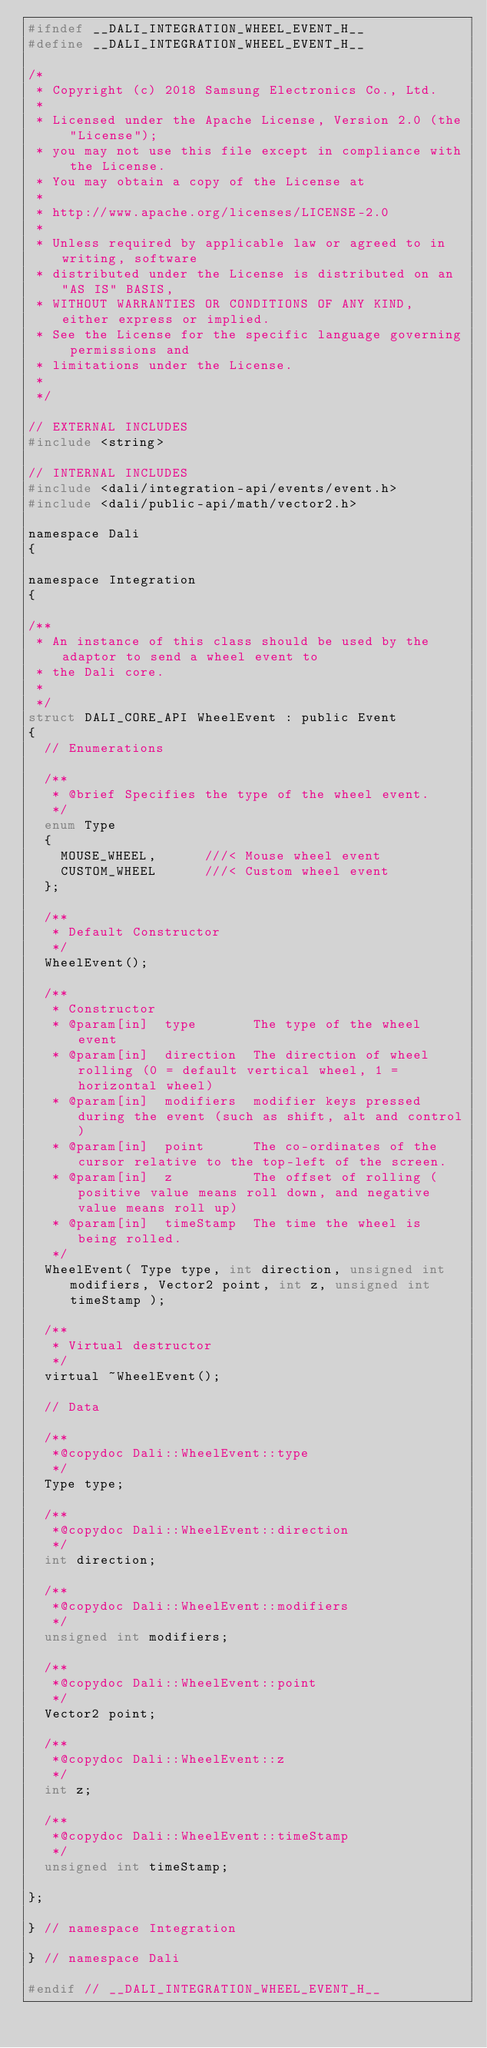<code> <loc_0><loc_0><loc_500><loc_500><_C_>#ifndef __DALI_INTEGRATION_WHEEL_EVENT_H__
#define __DALI_INTEGRATION_WHEEL_EVENT_H__

/*
 * Copyright (c) 2018 Samsung Electronics Co., Ltd.
 *
 * Licensed under the Apache License, Version 2.0 (the "License");
 * you may not use this file except in compliance with the License.
 * You may obtain a copy of the License at
 *
 * http://www.apache.org/licenses/LICENSE-2.0
 *
 * Unless required by applicable law or agreed to in writing, software
 * distributed under the License is distributed on an "AS IS" BASIS,
 * WITHOUT WARRANTIES OR CONDITIONS OF ANY KIND, either express or implied.
 * See the License for the specific language governing permissions and
 * limitations under the License.
 *
 */

// EXTERNAL INCLUDES
#include <string>

// INTERNAL INCLUDES
#include <dali/integration-api/events/event.h>
#include <dali/public-api/math/vector2.h>

namespace Dali
{

namespace Integration
{

/**
 * An instance of this class should be used by the adaptor to send a wheel event to
 * the Dali core.
 *
 */
struct DALI_CORE_API WheelEvent : public Event
{
  // Enumerations

  /**
   * @brief Specifies the type of the wheel event.
   */
  enum Type
  {
    MOUSE_WHEEL,      ///< Mouse wheel event
    CUSTOM_WHEEL      ///< Custom wheel event
  };

  /**
   * Default Constructor
   */
  WheelEvent();

  /**
   * Constructor
   * @param[in]  type       The type of the wheel event
   * @param[in]  direction  The direction of wheel rolling (0 = default vertical wheel, 1 = horizontal wheel)
   * @param[in]  modifiers  modifier keys pressed during the event (such as shift, alt and control)
   * @param[in]  point      The co-ordinates of the cursor relative to the top-left of the screen.
   * @param[in]  z          The offset of rolling (positive value means roll down, and negative value means roll up)
   * @param[in]  timeStamp  The time the wheel is being rolled.
   */
  WheelEvent( Type type, int direction, unsigned int modifiers, Vector2 point, int z, unsigned int timeStamp );

  /**
   * Virtual destructor
   */
  virtual ~WheelEvent();

  // Data

  /**
   *@copydoc Dali::WheelEvent::type
   */
  Type type;

  /**
   *@copydoc Dali::WheelEvent::direction
   */
  int direction;

  /**
   *@copydoc Dali::WheelEvent::modifiers
   */
  unsigned int modifiers;

  /**
   *@copydoc Dali::WheelEvent::point
   */
  Vector2 point;

  /**
   *@copydoc Dali::WheelEvent::z
   */
  int z;

  /**
   *@copydoc Dali::WheelEvent::timeStamp
   */
  unsigned int timeStamp;

};

} // namespace Integration

} // namespace Dali

#endif // __DALI_INTEGRATION_WHEEL_EVENT_H__
</code> 